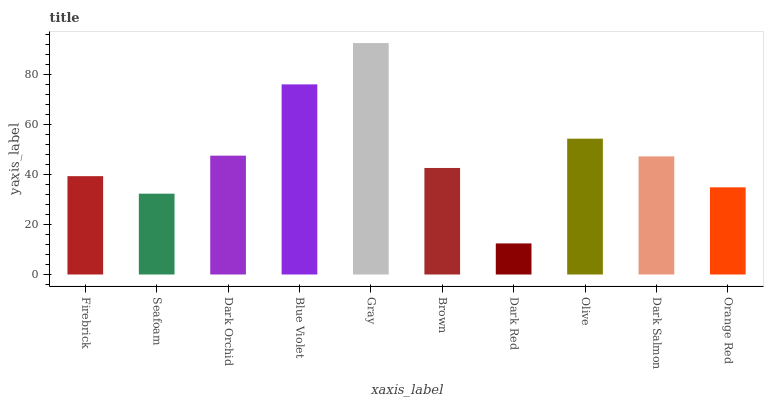Is Dark Red the minimum?
Answer yes or no. Yes. Is Gray the maximum?
Answer yes or no. Yes. Is Seafoam the minimum?
Answer yes or no. No. Is Seafoam the maximum?
Answer yes or no. No. Is Firebrick greater than Seafoam?
Answer yes or no. Yes. Is Seafoam less than Firebrick?
Answer yes or no. Yes. Is Seafoam greater than Firebrick?
Answer yes or no. No. Is Firebrick less than Seafoam?
Answer yes or no. No. Is Dark Salmon the high median?
Answer yes or no. Yes. Is Brown the low median?
Answer yes or no. Yes. Is Seafoam the high median?
Answer yes or no. No. Is Gray the low median?
Answer yes or no. No. 